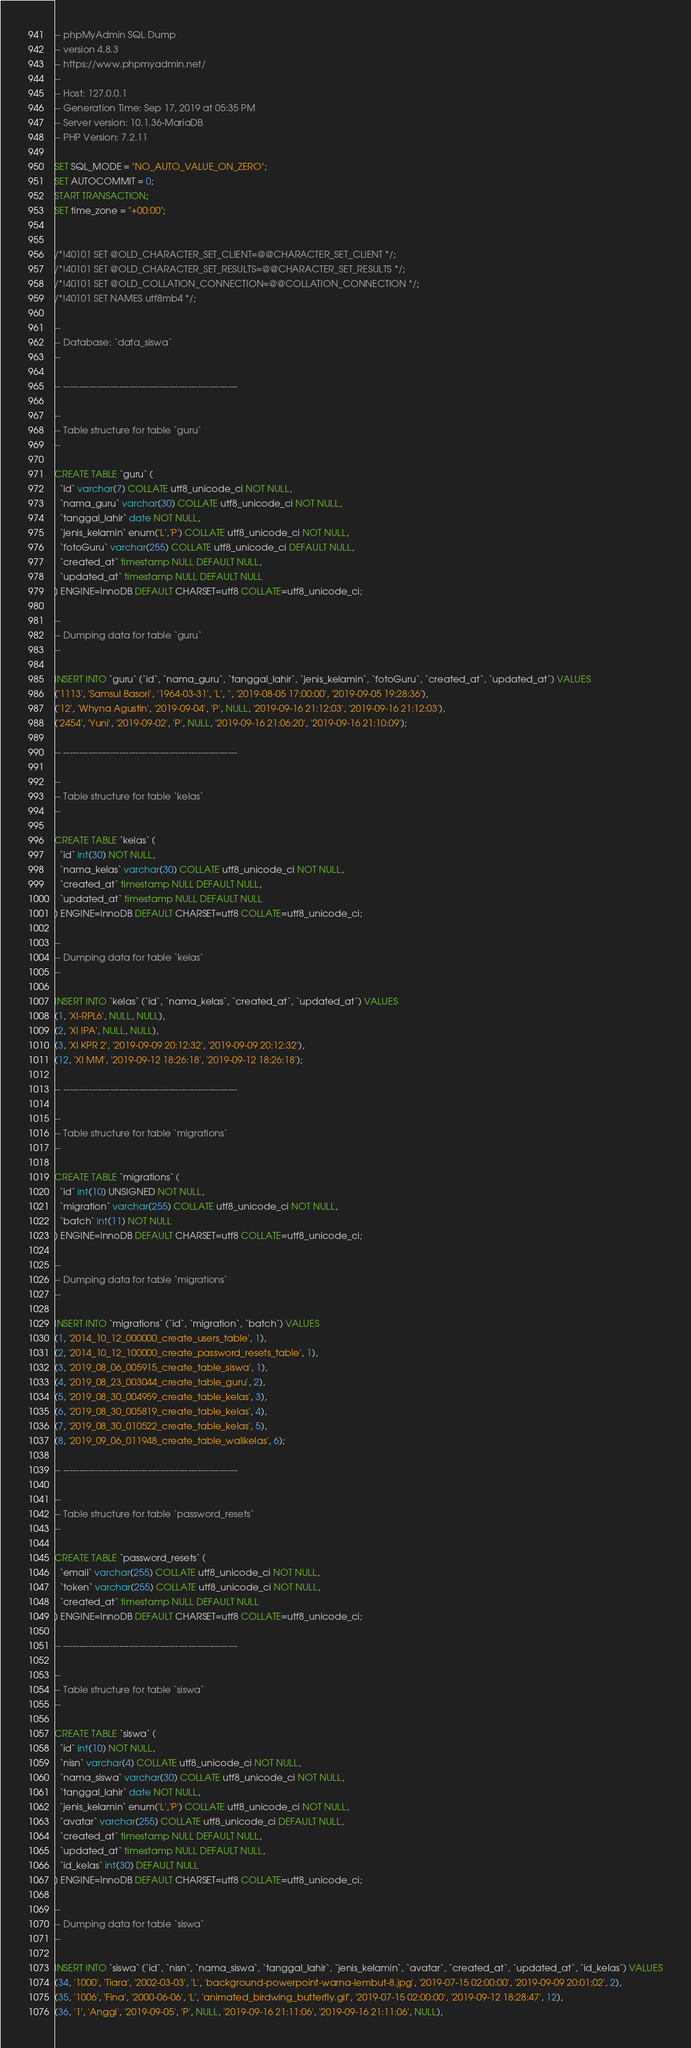Convert code to text. <code><loc_0><loc_0><loc_500><loc_500><_SQL_>-- phpMyAdmin SQL Dump
-- version 4.8.3
-- https://www.phpmyadmin.net/
--
-- Host: 127.0.0.1
-- Generation Time: Sep 17, 2019 at 05:35 PM
-- Server version: 10.1.36-MariaDB
-- PHP Version: 7.2.11

SET SQL_MODE = "NO_AUTO_VALUE_ON_ZERO";
SET AUTOCOMMIT = 0;
START TRANSACTION;
SET time_zone = "+00:00";


/*!40101 SET @OLD_CHARACTER_SET_CLIENT=@@CHARACTER_SET_CLIENT */;
/*!40101 SET @OLD_CHARACTER_SET_RESULTS=@@CHARACTER_SET_RESULTS */;
/*!40101 SET @OLD_COLLATION_CONNECTION=@@COLLATION_CONNECTION */;
/*!40101 SET NAMES utf8mb4 */;

--
-- Database: `data_siswa`
--

-- --------------------------------------------------------

--
-- Table structure for table `guru`
--

CREATE TABLE `guru` (
  `id` varchar(7) COLLATE utf8_unicode_ci NOT NULL,
  `nama_guru` varchar(30) COLLATE utf8_unicode_ci NOT NULL,
  `tanggal_lahir` date NOT NULL,
  `jenis_kelamin` enum('L','P') COLLATE utf8_unicode_ci NOT NULL,
  `fotoGuru` varchar(255) COLLATE utf8_unicode_ci DEFAULT NULL,
  `created_at` timestamp NULL DEFAULT NULL,
  `updated_at` timestamp NULL DEFAULT NULL
) ENGINE=InnoDB DEFAULT CHARSET=utf8 COLLATE=utf8_unicode_ci;

--
-- Dumping data for table `guru`
--

INSERT INTO `guru` (`id`, `nama_guru`, `tanggal_lahir`, `jenis_kelamin`, `fotoGuru`, `created_at`, `updated_at`) VALUES
('1113', 'Samsul Basori', '1964-03-31', 'L', '', '2019-08-05 17:00:00', '2019-09-05 19:28:36'),
('12', 'Whyna Agustin', '2019-09-04', 'P', NULL, '2019-09-16 21:12:03', '2019-09-16 21:12:03'),
('2454', 'Yuni', '2019-09-02', 'P', NULL, '2019-09-16 21:06:20', '2019-09-16 21:10:09');

-- --------------------------------------------------------

--
-- Table structure for table `kelas`
--

CREATE TABLE `kelas` (
  `id` int(30) NOT NULL,
  `nama_kelas` varchar(30) COLLATE utf8_unicode_ci NOT NULL,
  `created_at` timestamp NULL DEFAULT NULL,
  `updated_at` timestamp NULL DEFAULT NULL
) ENGINE=InnoDB DEFAULT CHARSET=utf8 COLLATE=utf8_unicode_ci;

--
-- Dumping data for table `kelas`
--

INSERT INTO `kelas` (`id`, `nama_kelas`, `created_at`, `updated_at`) VALUES
(1, 'XI-RPL6', NULL, NULL),
(2, 'XI IPA', NULL, NULL),
(3, 'XI KPR 2', '2019-09-09 20:12:32', '2019-09-09 20:12:32'),
(12, 'XI MM', '2019-09-12 18:26:18', '2019-09-12 18:26:18');

-- --------------------------------------------------------

--
-- Table structure for table `migrations`
--

CREATE TABLE `migrations` (
  `id` int(10) UNSIGNED NOT NULL,
  `migration` varchar(255) COLLATE utf8_unicode_ci NOT NULL,
  `batch` int(11) NOT NULL
) ENGINE=InnoDB DEFAULT CHARSET=utf8 COLLATE=utf8_unicode_ci;

--
-- Dumping data for table `migrations`
--

INSERT INTO `migrations` (`id`, `migration`, `batch`) VALUES
(1, '2014_10_12_000000_create_users_table', 1),
(2, '2014_10_12_100000_create_password_resets_table', 1),
(3, '2019_08_06_005915_create_table_siswa', 1),
(4, '2019_08_23_003044_create_table_guru', 2),
(5, '2019_08_30_004959_create_table_kelas', 3),
(6, '2019_08_30_005819_create_table_kelas', 4),
(7, '2019_08_30_010522_create_table_kelas', 5),
(8, '2019_09_06_011948_create_table_walikelas', 6);

-- --------------------------------------------------------

--
-- Table structure for table `password_resets`
--

CREATE TABLE `password_resets` (
  `email` varchar(255) COLLATE utf8_unicode_ci NOT NULL,
  `token` varchar(255) COLLATE utf8_unicode_ci NOT NULL,
  `created_at` timestamp NULL DEFAULT NULL
) ENGINE=InnoDB DEFAULT CHARSET=utf8 COLLATE=utf8_unicode_ci;

-- --------------------------------------------------------

--
-- Table structure for table `siswa`
--

CREATE TABLE `siswa` (
  `id` int(10) NOT NULL,
  `nisn` varchar(4) COLLATE utf8_unicode_ci NOT NULL,
  `nama_siswa` varchar(30) COLLATE utf8_unicode_ci NOT NULL,
  `tanggal_lahir` date NOT NULL,
  `jenis_kelamin` enum('L','P') COLLATE utf8_unicode_ci NOT NULL,
  `avatar` varchar(255) COLLATE utf8_unicode_ci DEFAULT NULL,
  `created_at` timestamp NULL DEFAULT NULL,
  `updated_at` timestamp NULL DEFAULT NULL,
  `id_kelas` int(30) DEFAULT NULL
) ENGINE=InnoDB DEFAULT CHARSET=utf8 COLLATE=utf8_unicode_ci;

--
-- Dumping data for table `siswa`
--

INSERT INTO `siswa` (`id`, `nisn`, `nama_siswa`, `tanggal_lahir`, `jenis_kelamin`, `avatar`, `created_at`, `updated_at`, `id_kelas`) VALUES
(34, '1000', 'Tiara', '2002-03-03', 'L', 'background-powerpoint-warna-lembut-8.jpg', '2019-07-15 02:00:00', '2019-09-09 20:01:02', 2),
(35, '1006', 'Fina', '2000-06-06', 'L', 'animated_birdwing_butterfly.gif', '2019-07-15 02:00:00', '2019-09-12 18:28:47', 12),
(36, '1', 'Anggi', '2019-09-05', 'P', NULL, '2019-09-16 21:11:06', '2019-09-16 21:11:06', NULL),</code> 